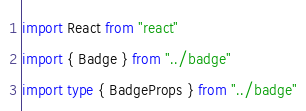<code> <loc_0><loc_0><loc_500><loc_500><_TypeScript_>
import React from "react"
import { Badge } from "../badge"
import type { BadgeProps } from "../badge"
</code> 